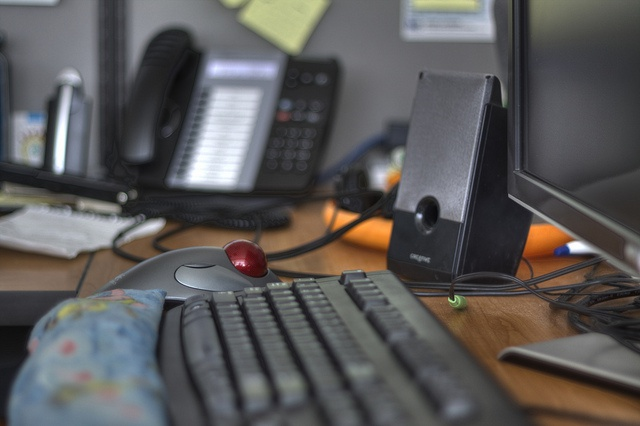Describe the objects in this image and their specific colors. I can see keyboard in darkgray, gray, and black tones, tv in darkgray, gray, and black tones, mouse in darkgray, gray, maroon, and black tones, bottle in darkgray, gray, white, and black tones, and keyboard in darkgray, gray, and lightgray tones in this image. 